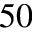Convert formula to latex. <formula><loc_0><loc_0><loc_500><loc_500>^ { 5 0 }</formula> 